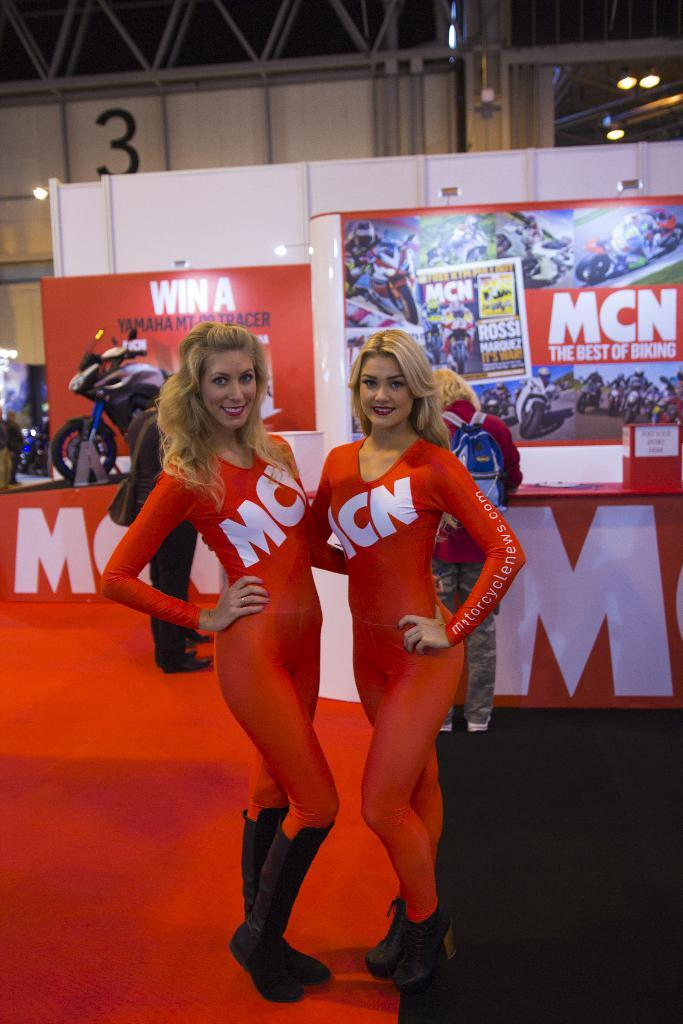<image>
Give a short and clear explanation of the subsequent image. MCN is shown as an advert on these two model's outfits. 